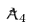<formula> <loc_0><loc_0><loc_500><loc_500>\tilde { A } _ { 4 }</formula> 